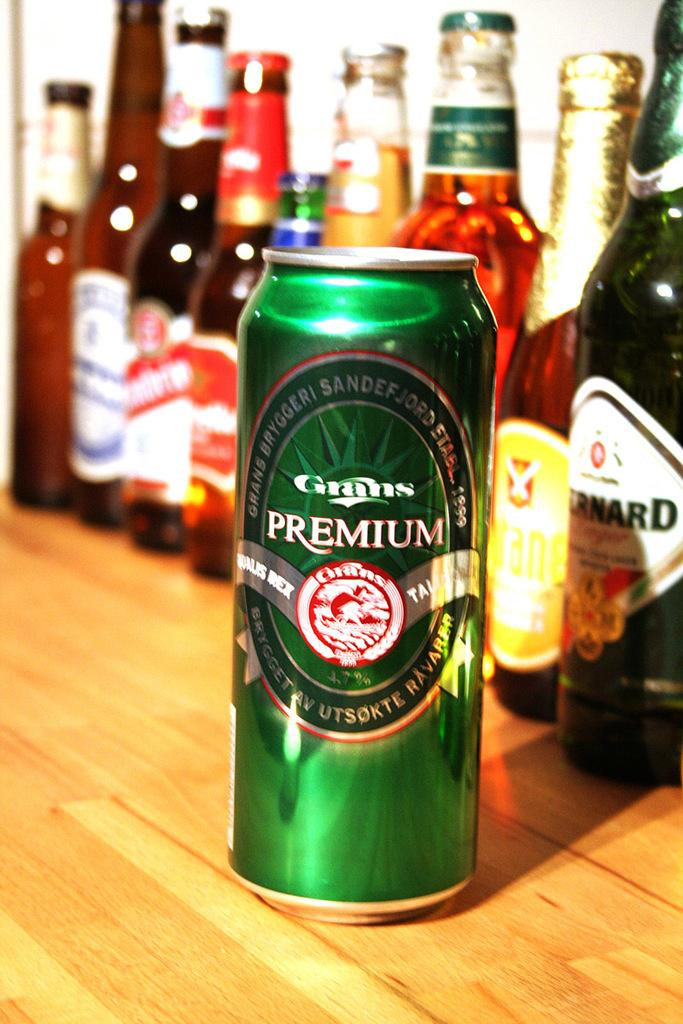Provide a one-sentence caption for the provided image. Tall and green Grans Premium beer in front of other beer bottles. 